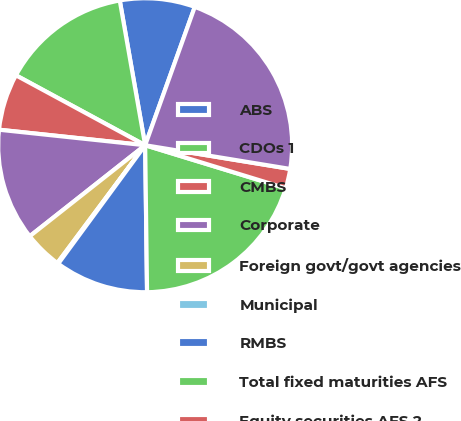Convert chart to OTSL. <chart><loc_0><loc_0><loc_500><loc_500><pie_chart><fcel>ABS<fcel>CDOs 1<fcel>CMBS<fcel>Corporate<fcel>Foreign govt/govt agencies<fcel>Municipal<fcel>RMBS<fcel>Total fixed maturities AFS<fcel>Equity securities AFS 2<fcel>Total securities in an<nl><fcel>8.25%<fcel>14.34%<fcel>6.21%<fcel>12.31%<fcel>4.18%<fcel>0.12%<fcel>10.28%<fcel>20.07%<fcel>2.15%<fcel>22.1%<nl></chart> 